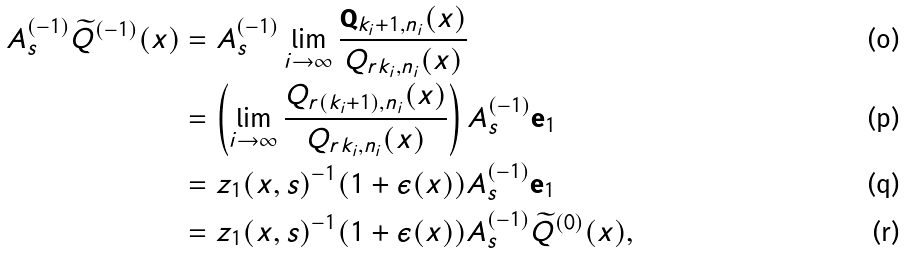<formula> <loc_0><loc_0><loc_500><loc_500>A _ { s } ^ { ( - 1 ) } \widetilde { Q } ^ { ( - 1 ) } ( x ) & = A _ { s } ^ { ( - 1 ) } \lim _ { i \to \infty } \frac { \mathbf Q _ { k _ { i } + 1 , n _ { i } } ( x ) } { Q _ { r k _ { i } , n _ { i } } ( x ) } \\ & = \left ( \lim _ { i \to \infty } \frac { Q _ { r ( k _ { i } + 1 ) , n _ { i } } ( x ) } { Q _ { r k _ { i } , n _ { i } } ( x ) } \right ) A _ { s } ^ { ( - 1 ) } \mathbf e _ { 1 } \\ & = z _ { 1 } ( x , s ) ^ { - 1 } ( 1 + \epsilon ( x ) ) A _ { s } ^ { ( - 1 ) } \mathbf e _ { 1 } \\ & = z _ { 1 } ( x , s ) ^ { - 1 } ( 1 + \epsilon ( x ) ) A _ { s } ^ { ( - 1 ) } \widetilde { Q } ^ { ( 0 ) } ( x ) ,</formula> 